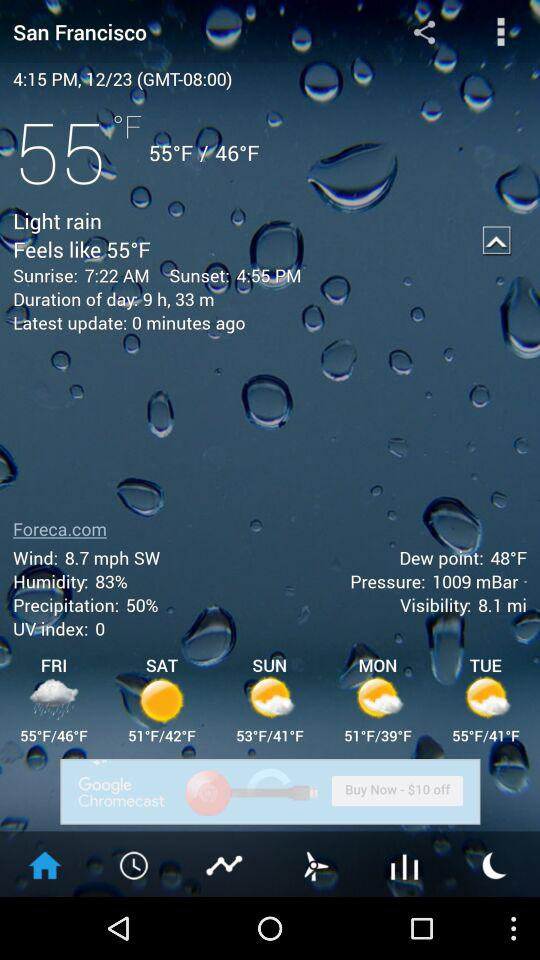What is the time? The time is 4:15 p.m. 